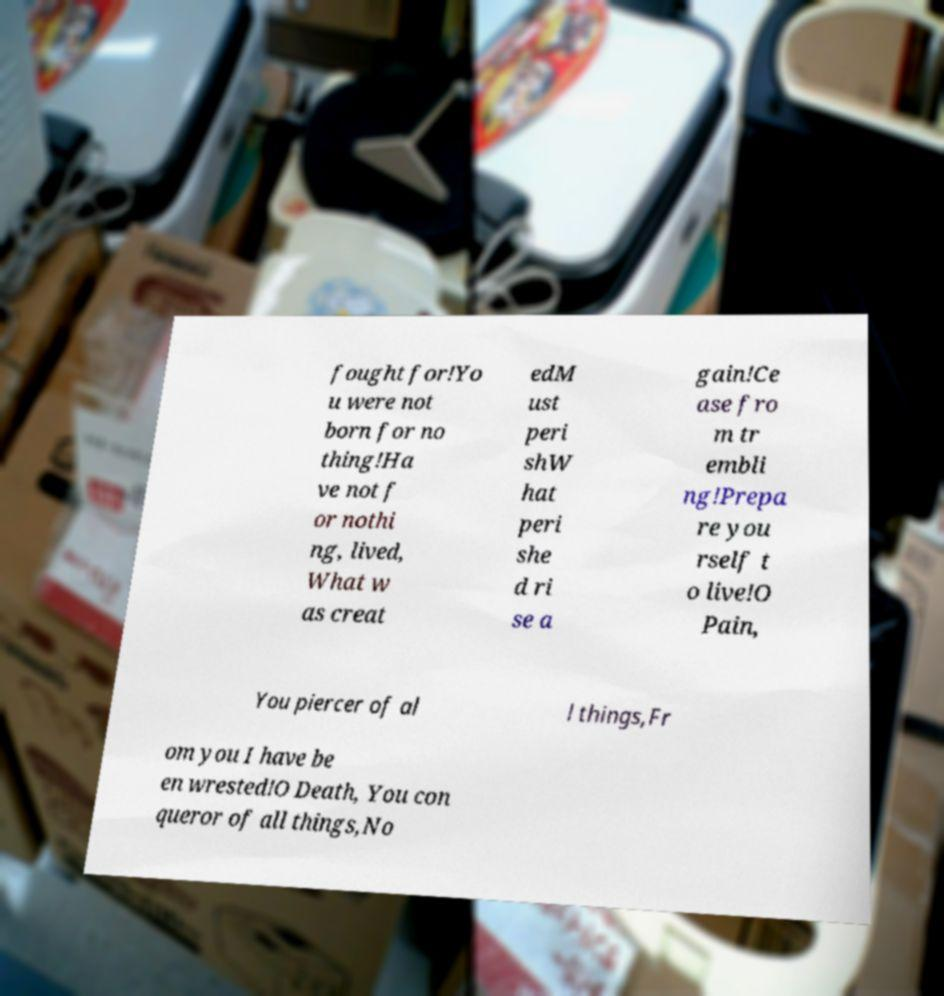Could you assist in decoding the text presented in this image and type it out clearly? fought for!Yo u were not born for no thing!Ha ve not f or nothi ng, lived, What w as creat edM ust peri shW hat peri she d ri se a gain!Ce ase fro m tr embli ng!Prepa re you rself t o live!O Pain, You piercer of al l things,Fr om you I have be en wrested!O Death, You con queror of all things,No 